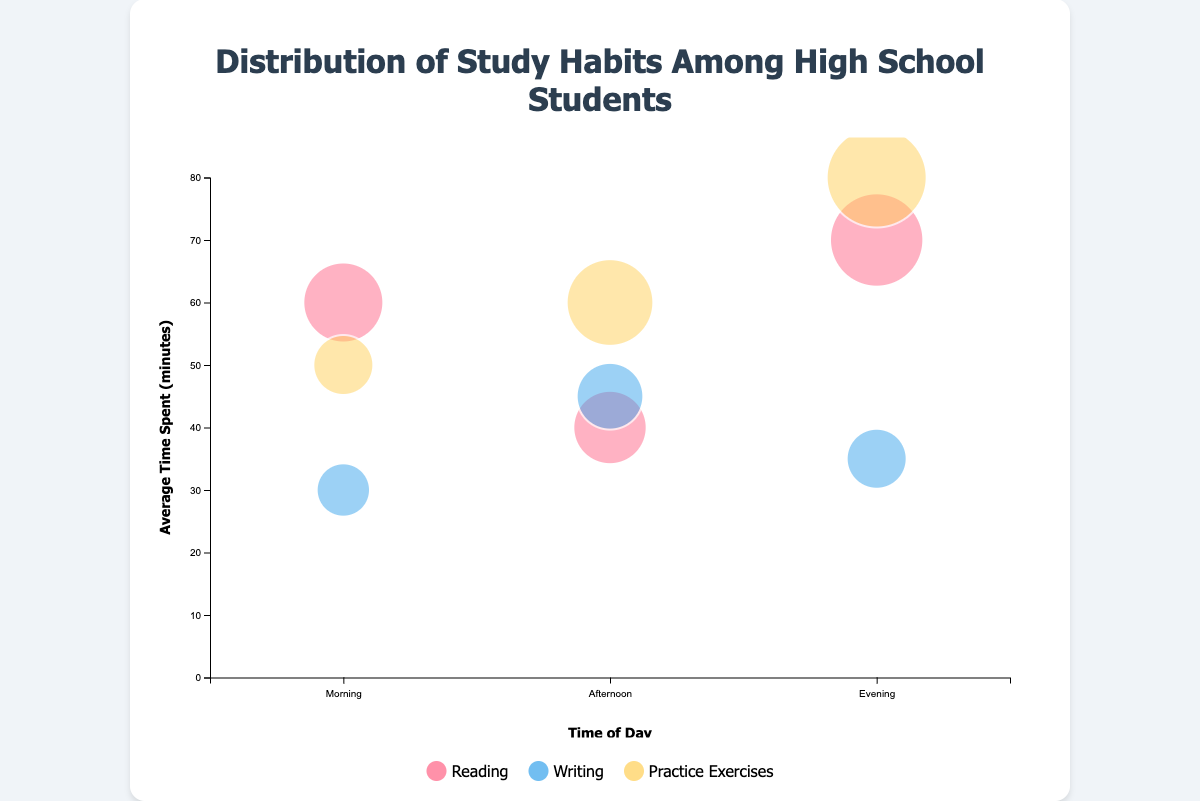What is the title of the chart? The title is usually positioned at the top of the chart and describes the main content or topic. Here, it states "Distribution of Study Habits Among High School Students."
Answer: Distribution of Study Habits Among High School Students How is the number of students represented in the chart? In a bubble chart, the size of the bubbles typically corresponds to the numerical values being visualized. Here, larger bubbles indicate a greater number of students.
Answer: Size of the bubbles Which time of day and activity combination has the smallest average time spent on it? By looking at the y-axis (Average Time Spent) and identifying the bubble that is closest to the x-axis, "Morning Writing" represents students spending 30 minutes on average, which is the lowest.
Answer: Morning Writing During which time of day do students spend the most time reading? We need to find the bubble for Reading with the highest value on the y-axis. The "Evening" bubble for Reading has an average time spent of 70 minutes, the highest for reading.
Answer: Evening Which activity has the highest average time spent in the evening? For activities in the evening, we compare the y-values of the bubbles. "Practice Exercises" in the evening stands out with an average time spent of 80 minutes.
Answer: Practice Exercises Compare the number of students doing practice exercises in the morning vs the evening. Which is more? We compare the sizes of the respective bubbles. The "Practice Exercises" bubble in the evening is larger than the one in the morning, indicating more students (60 vs. 30).
Answer: Evening What's the combined average time spent on writing across all times of day? We add the average times from each time of day for writing: Morning (30 minutes), Afternoon (45 minutes), and Evening (35 minutes). (30 + 45 + 35 = 110 minutes).
Answer: 110 minutes Do more students engage in practice exercises in the afternoon or evening? We compare the sizes of the bubbles for "Practice Exercises." The evening bubble is larger, representing 60 students, compared to 50 students in the afternoon.
Answer: Evening On average, how much more time do students spend on reading in the evening compared to the afternoon? We subtract the average time spent on Reading in the afternoon (40 minutes) from that in the evening (70 minutes). (70 - 40 = 30 minutes).
Answer: 30 minutes 